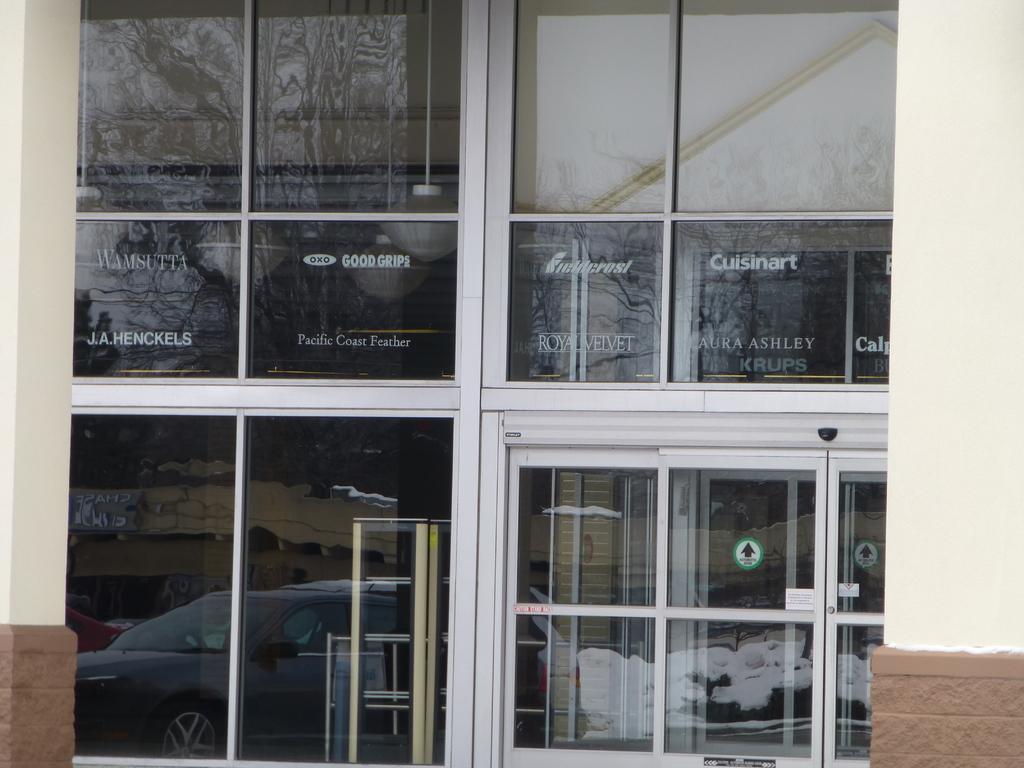Describe this image in one or two sentences. In the picture I can see glass doors on which we can see the reflection of vehicles on the road and can see the reflection of buildings. 